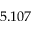<formula> <loc_0><loc_0><loc_500><loc_500>5 . 1 0 7</formula> 